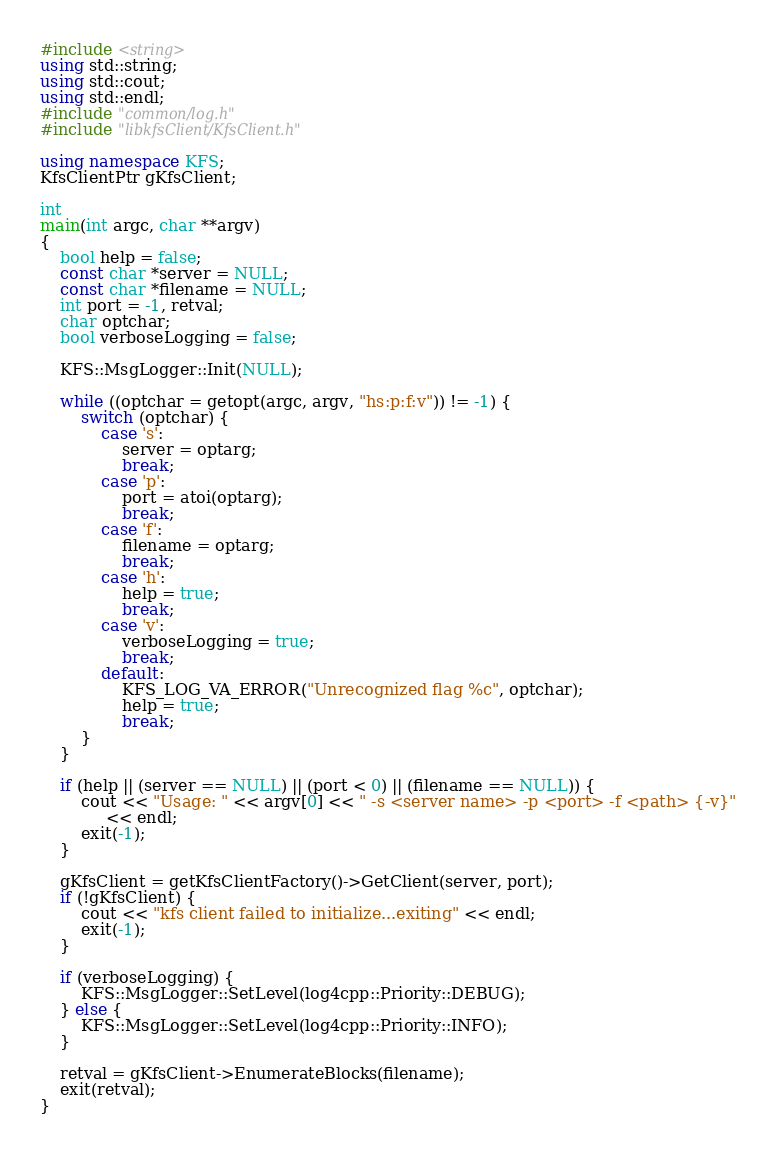Convert code to text. <code><loc_0><loc_0><loc_500><loc_500><_C++_>#include <string>
using std::string;
using std::cout;
using std::endl;
#include "common/log.h"
#include "libkfsClient/KfsClient.h"

using namespace KFS;
KfsClientPtr gKfsClient;

int
main(int argc, char **argv)
{
    bool help = false;
    const char *server = NULL;
    const char *filename = NULL;
    int port = -1, retval;
    char optchar;
    bool verboseLogging = false;

    KFS::MsgLogger::Init(NULL);

    while ((optchar = getopt(argc, argv, "hs:p:f:v")) != -1) {
        switch (optchar) {
            case 's':
                server = optarg;
                break;
            case 'p':
                port = atoi(optarg);
                break;
            case 'f':
                filename = optarg;
                break;
            case 'h':
                help = true;
                break;
            case 'v':
                verboseLogging = true;
                break;
            default:
                KFS_LOG_VA_ERROR("Unrecognized flag %c", optchar);
                help = true;
                break;
        }
    }

    if (help || (server == NULL) || (port < 0) || (filename == NULL)) {
        cout << "Usage: " << argv[0] << " -s <server name> -p <port> -f <path> {-v}" 
             << endl;
        exit(-1);
    }

    gKfsClient = getKfsClientFactory()->GetClient(server, port);
    if (!gKfsClient) {
        cout << "kfs client failed to initialize...exiting" << endl;
        exit(-1);
    }

    if (verboseLogging) {
        KFS::MsgLogger::SetLevel(log4cpp::Priority::DEBUG);
    } else {
        KFS::MsgLogger::SetLevel(log4cpp::Priority::INFO);
    } 

    retval = gKfsClient->EnumerateBlocks(filename);
    exit(retval);
}


</code> 